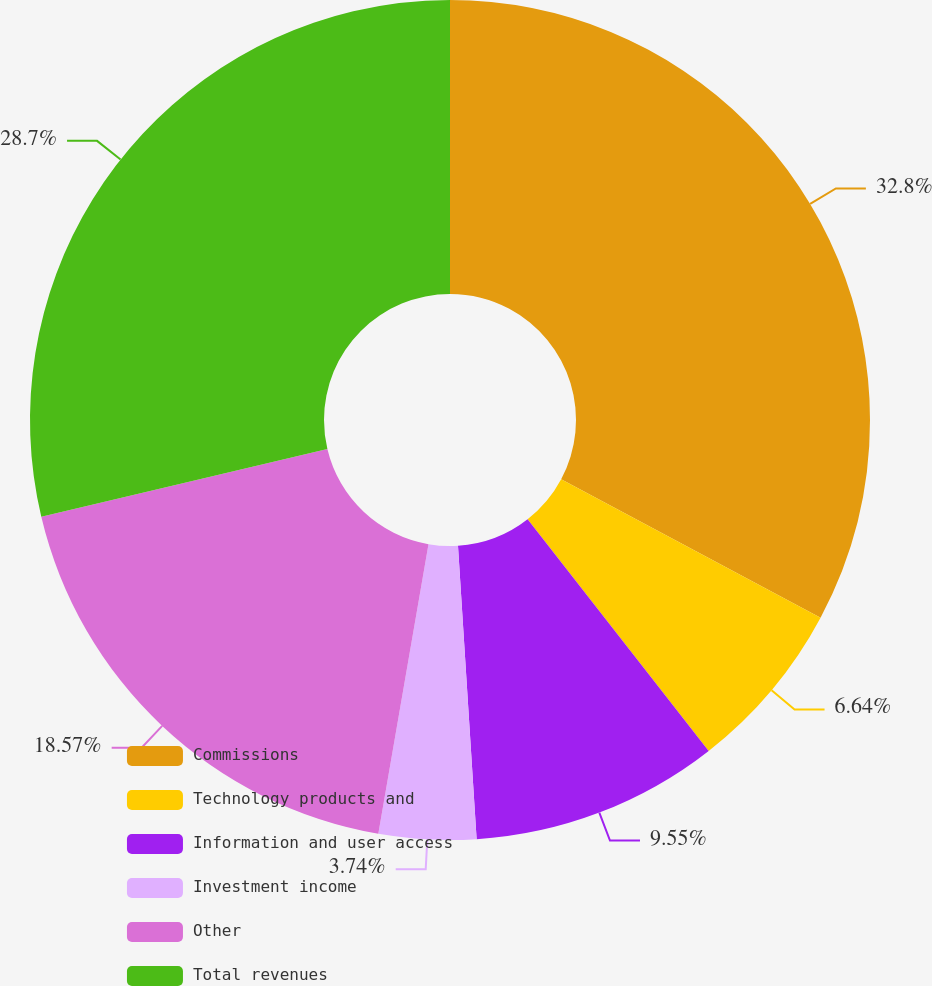Convert chart to OTSL. <chart><loc_0><loc_0><loc_500><loc_500><pie_chart><fcel>Commissions<fcel>Technology products and<fcel>Information and user access<fcel>Investment income<fcel>Other<fcel>Total revenues<nl><fcel>32.8%<fcel>6.64%<fcel>9.55%<fcel>3.74%<fcel>18.57%<fcel>28.7%<nl></chart> 